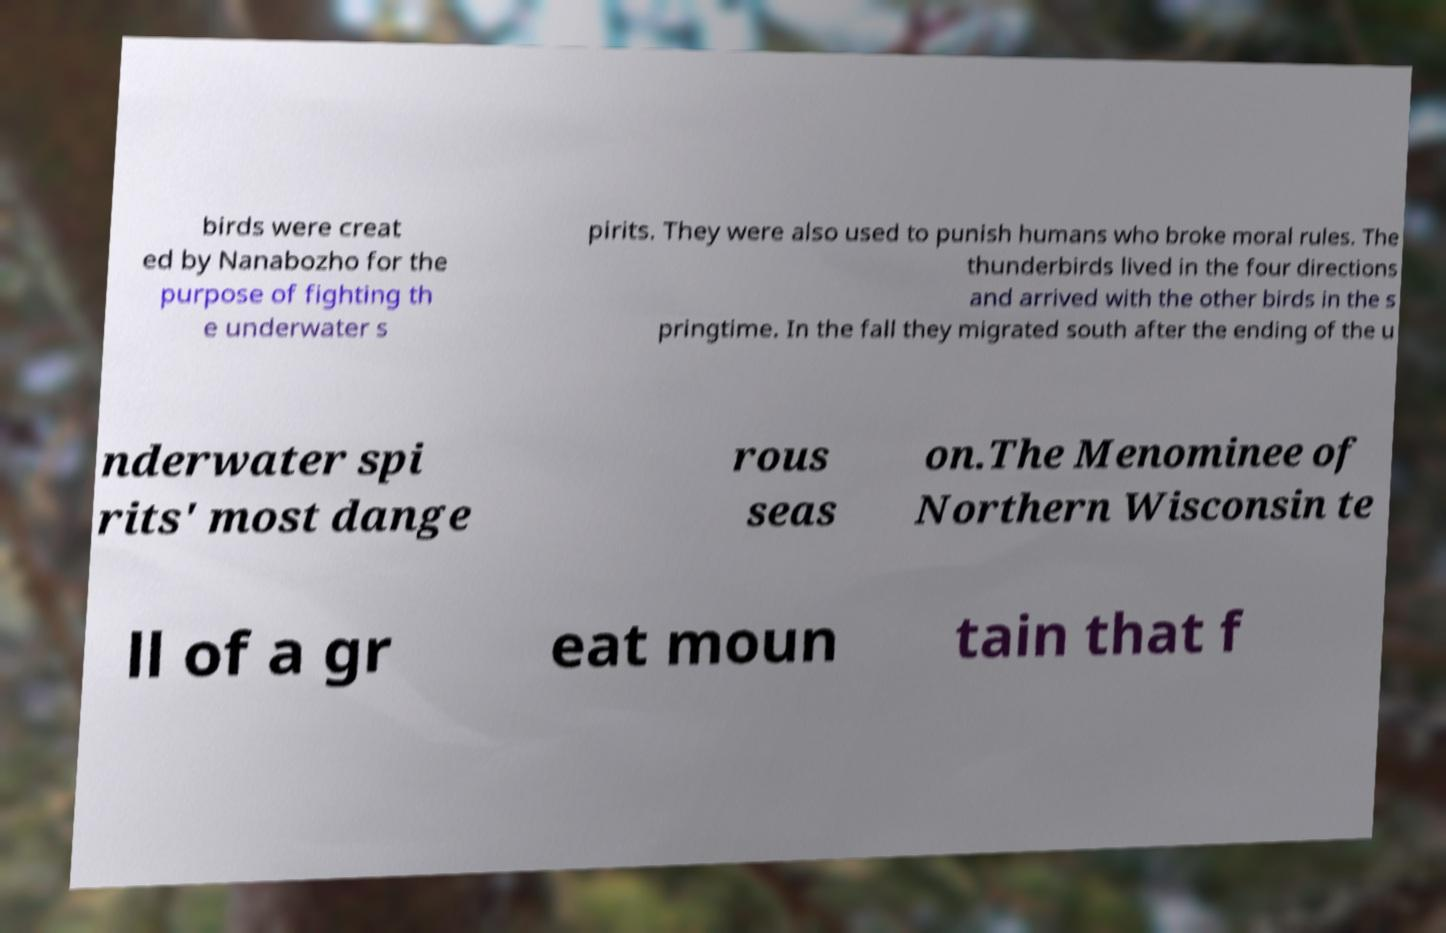There's text embedded in this image that I need extracted. Can you transcribe it verbatim? birds were creat ed by Nanabozho for the purpose of fighting th e underwater s pirits. They were also used to punish humans who broke moral rules. The thunderbirds lived in the four directions and arrived with the other birds in the s pringtime. In the fall they migrated south after the ending of the u nderwater spi rits' most dange rous seas on.The Menominee of Northern Wisconsin te ll of a gr eat moun tain that f 